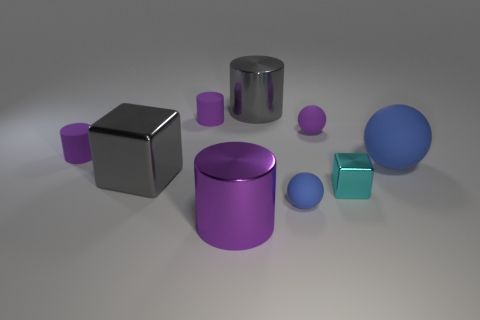There is a metal thing on the right side of the metal cylinder behind the blue matte ball that is on the right side of the tiny shiny object; what is its color?
Your answer should be very brief. Cyan. There is a rubber thing that is the same size as the gray metal cube; what shape is it?
Ensure brevity in your answer.  Sphere. Are there more large purple metal spheres than large rubber spheres?
Your response must be concise. No. Are there any tiny purple rubber spheres on the left side of the large cylinder that is left of the gray cylinder?
Give a very brief answer. No. What color is the other object that is the same shape as the cyan metallic thing?
Provide a short and direct response. Gray. Are there any other things that are the same shape as the big blue matte object?
Your answer should be compact. Yes. There is another cube that is made of the same material as the gray cube; what is its color?
Offer a terse response. Cyan. Are there any tiny purple rubber things that are to the right of the big matte thing on the right side of the purple cylinder in front of the small blue matte object?
Ensure brevity in your answer.  No. Are there fewer small blue matte spheres behind the gray metallic cylinder than small metal cubes that are left of the big purple metallic object?
Provide a succinct answer. No. What number of gray things have the same material as the big blue object?
Give a very brief answer. 0. 